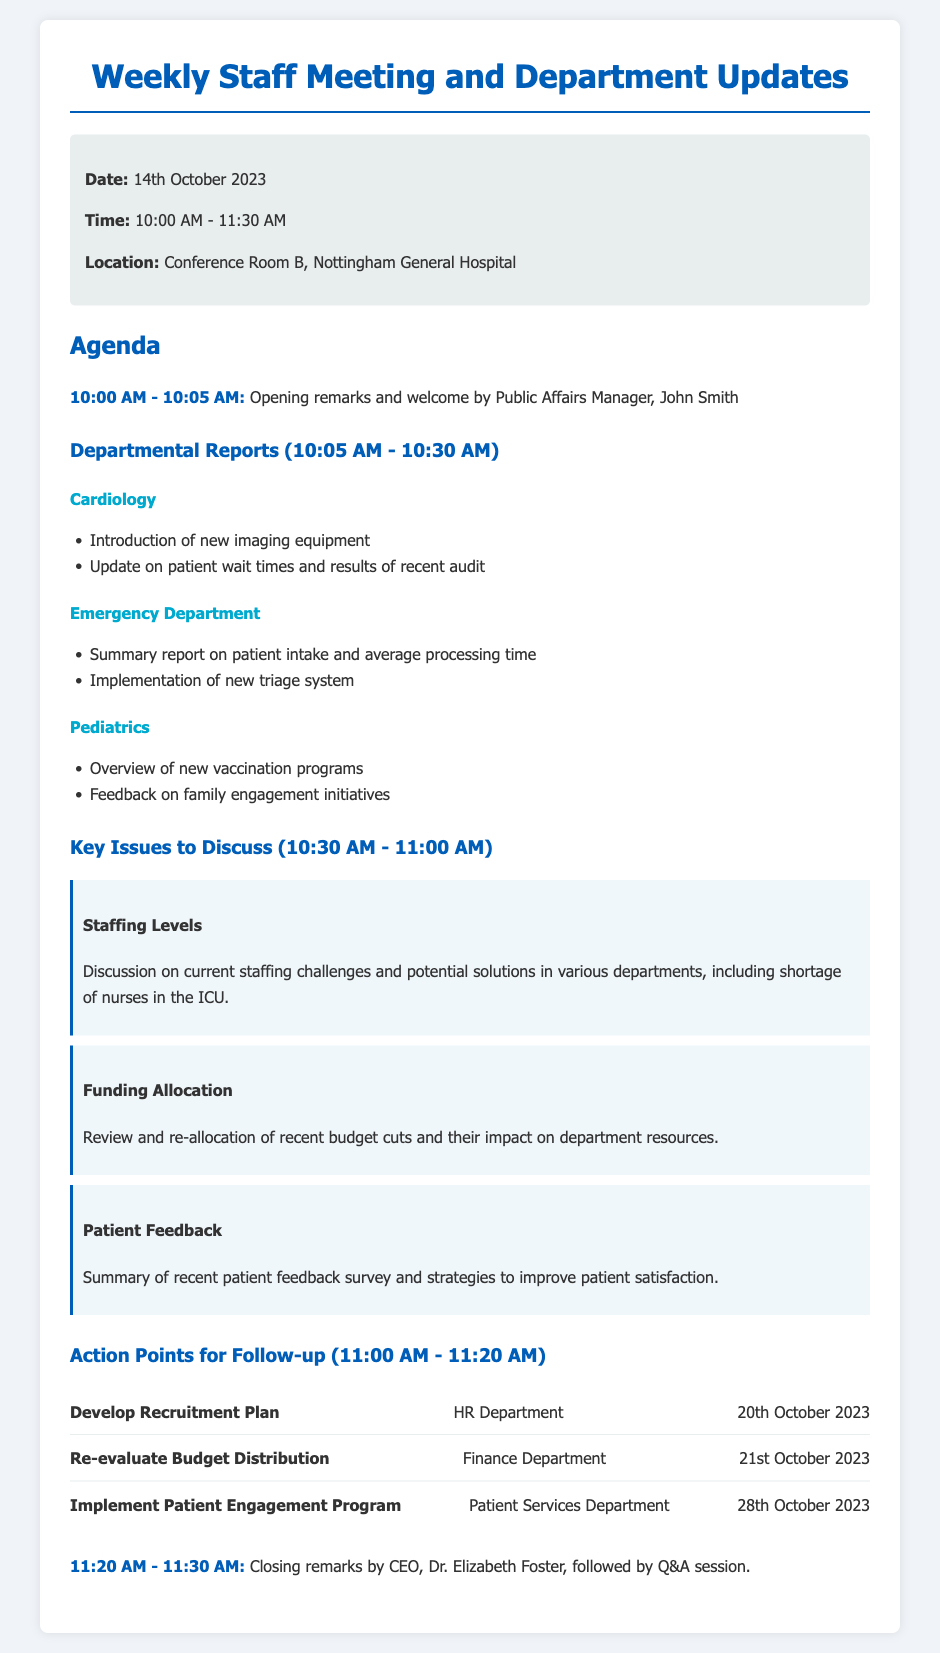What is the date of the meeting? The date of the meeting is stated clearly in the meeting details section.
Answer: 14th October 2023 Who is the Public Affairs Manager? The Public Affairs Manager is mentioned in the opening remarks.
Answer: John Smith What time does the meeting start? The starting time for the meeting is noted in the meeting details.
Answer: 10:00 AM Which department is introducing new imaging equipment? The report section lists departments and their updates.
Answer: Cardiology What is one key issue discussed regarding staffing levels? The document highlights several key issues, including the staffing levels.
Answer: Shortage of nurses in the ICU Which department is responsible for developing a recruitment plan? The action point assigns responsibilities to different departments.
Answer: HR Department When is the deadline for re-evaluating budget distribution? The action items include deadlines for follow-up tasks.
Answer: 21st October 2023 What is the location of the meeting? The location is specified in the meeting details section.
Answer: Conference Room B, Nottingham General Hospital What will happen during the closing remarks? The closing remarks section describes the activities at the end of the meeting.
Answer: Q&A session 